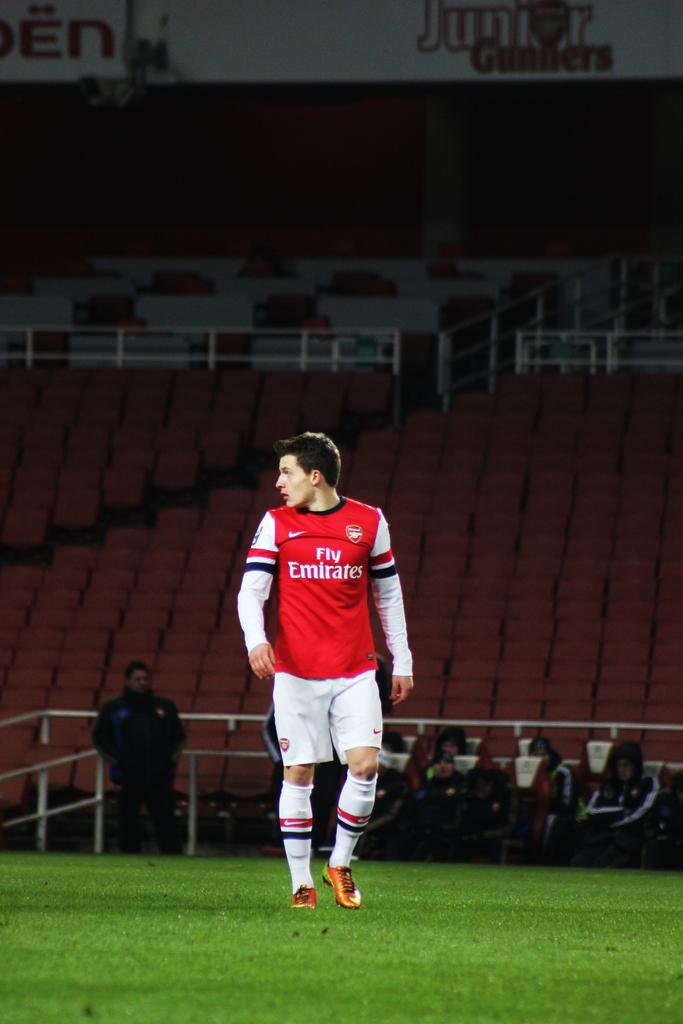<image>
Summarize the visual content of the image. a man who plays soccer for the fly emirites has a red jersey 